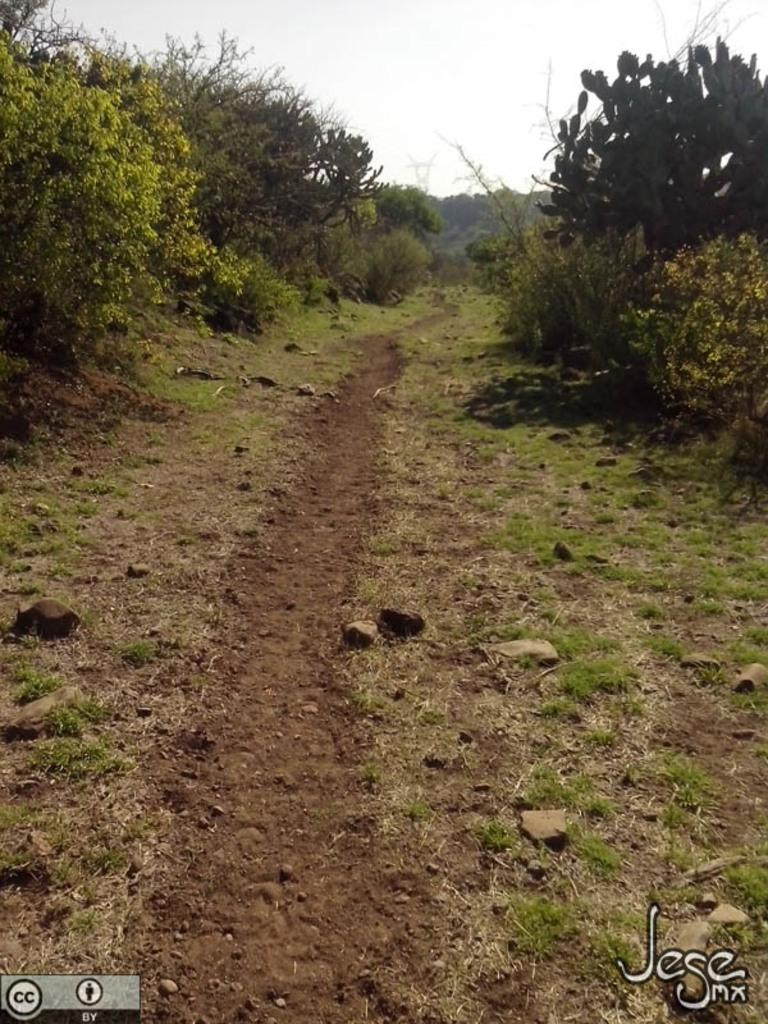What type of vegetation can be seen in the image? There are plants, trees, and grass visible in the image. What is the ground made of in the image? The ground is made of soil and stones in the image. What is visible in the background of the image? The sky is visible in the image. Is there any text present in the image? Yes, there is text on the right side of the image. Is there any indication of a watermark in the image? Yes, there is a watermark on the left side of the image. What type of jeans can be seen hanging on the tree in the image? There are no jeans present in the image; it features plants, trees, grass, soil, stones, the sky, text, and a watermark. What type of bait is used to attract the fish in the image? There is no mention of fish or bait in the image; it focuses on vegetation, soil, stones, the sky, text, and a watermark. 